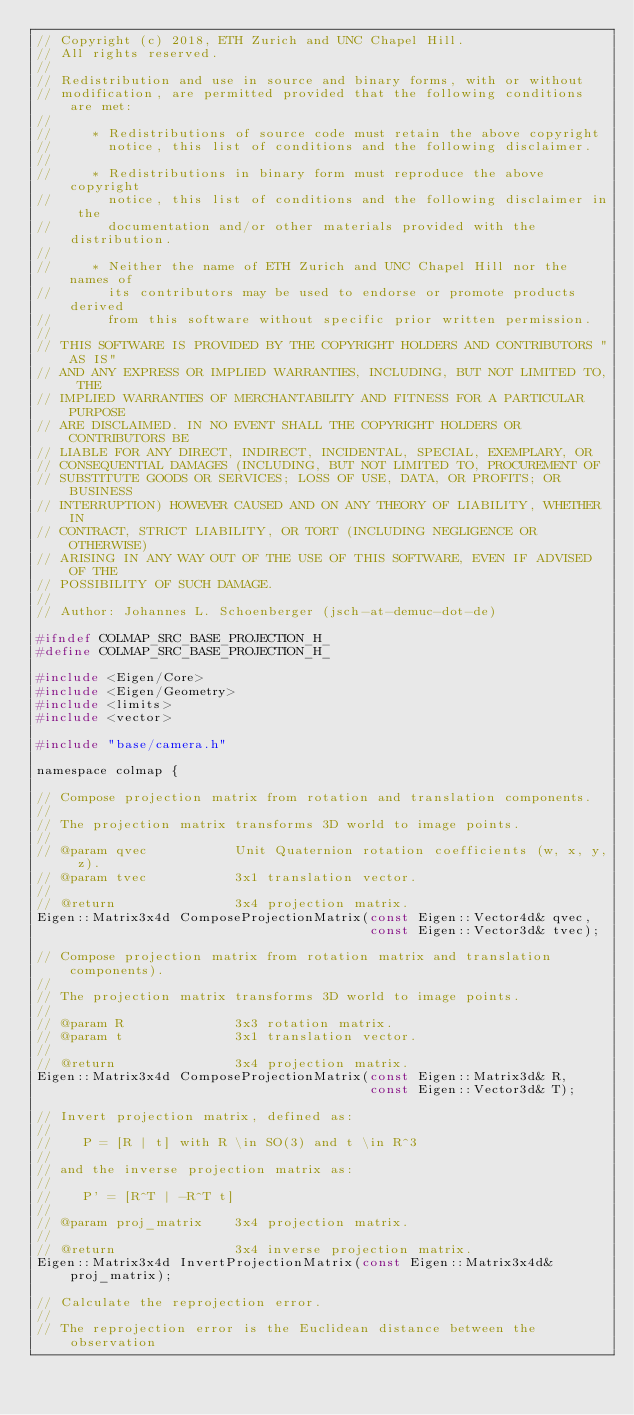Convert code to text. <code><loc_0><loc_0><loc_500><loc_500><_C_>// Copyright (c) 2018, ETH Zurich and UNC Chapel Hill.
// All rights reserved.
//
// Redistribution and use in source and binary forms, with or without
// modification, are permitted provided that the following conditions are met:
//
//     * Redistributions of source code must retain the above copyright
//       notice, this list of conditions and the following disclaimer.
//
//     * Redistributions in binary form must reproduce the above copyright
//       notice, this list of conditions and the following disclaimer in the
//       documentation and/or other materials provided with the distribution.
//
//     * Neither the name of ETH Zurich and UNC Chapel Hill nor the names of
//       its contributors may be used to endorse or promote products derived
//       from this software without specific prior written permission.
//
// THIS SOFTWARE IS PROVIDED BY THE COPYRIGHT HOLDERS AND CONTRIBUTORS "AS IS"
// AND ANY EXPRESS OR IMPLIED WARRANTIES, INCLUDING, BUT NOT LIMITED TO, THE
// IMPLIED WARRANTIES OF MERCHANTABILITY AND FITNESS FOR A PARTICULAR PURPOSE
// ARE DISCLAIMED. IN NO EVENT SHALL THE COPYRIGHT HOLDERS OR CONTRIBUTORS BE
// LIABLE FOR ANY DIRECT, INDIRECT, INCIDENTAL, SPECIAL, EXEMPLARY, OR
// CONSEQUENTIAL DAMAGES (INCLUDING, BUT NOT LIMITED TO, PROCUREMENT OF
// SUBSTITUTE GOODS OR SERVICES; LOSS OF USE, DATA, OR PROFITS; OR BUSINESS
// INTERRUPTION) HOWEVER CAUSED AND ON ANY THEORY OF LIABILITY, WHETHER IN
// CONTRACT, STRICT LIABILITY, OR TORT (INCLUDING NEGLIGENCE OR OTHERWISE)
// ARISING IN ANY WAY OUT OF THE USE OF THIS SOFTWARE, EVEN IF ADVISED OF THE
// POSSIBILITY OF SUCH DAMAGE.
//
// Author: Johannes L. Schoenberger (jsch-at-demuc-dot-de)

#ifndef COLMAP_SRC_BASE_PROJECTION_H_
#define COLMAP_SRC_BASE_PROJECTION_H_

#include <Eigen/Core>
#include <Eigen/Geometry>
#include <limits>
#include <vector>

#include "base/camera.h"

namespace colmap {

// Compose projection matrix from rotation and translation components.
//
// The projection matrix transforms 3D world to image points.
//
// @param qvec           Unit Quaternion rotation coefficients (w, x, y, z).
// @param tvec           3x1 translation vector.
//
// @return               3x4 projection matrix.
Eigen::Matrix3x4d ComposeProjectionMatrix(const Eigen::Vector4d& qvec,
                                          const Eigen::Vector3d& tvec);

// Compose projection matrix from rotation matrix and translation components).
//
// The projection matrix transforms 3D world to image points.
//
// @param R              3x3 rotation matrix.
// @param t              3x1 translation vector.
//
// @return               3x4 projection matrix.
Eigen::Matrix3x4d ComposeProjectionMatrix(const Eigen::Matrix3d& R,
                                          const Eigen::Vector3d& T);

// Invert projection matrix, defined as:
//
//    P = [R | t] with R \in SO(3) and t \in R^3
//
// and the inverse projection matrix as:
//
//    P' = [R^T | -R^T t]
//
// @param proj_matrix    3x4 projection matrix.
//
// @return               3x4 inverse projection matrix.
Eigen::Matrix3x4d InvertProjectionMatrix(const Eigen::Matrix3x4d& proj_matrix);

// Calculate the reprojection error.
//
// The reprojection error is the Euclidean distance between the observation</code> 